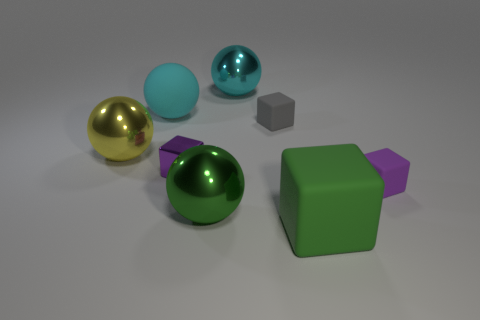Subtract all gray spheres. Subtract all blue cylinders. How many spheres are left? 4 Add 2 big blue cylinders. How many objects exist? 10 Subtract all purple cubes. Subtract all small cubes. How many objects are left? 3 Add 3 big green matte cubes. How many big green matte cubes are left? 4 Add 3 green balls. How many green balls exist? 4 Subtract 1 green spheres. How many objects are left? 7 